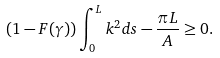<formula> <loc_0><loc_0><loc_500><loc_500>( 1 - F ( \gamma ) ) \int ^ { L } _ { 0 } k ^ { 2 } d s - \frac { \pi L } { A } \geq 0 .</formula> 